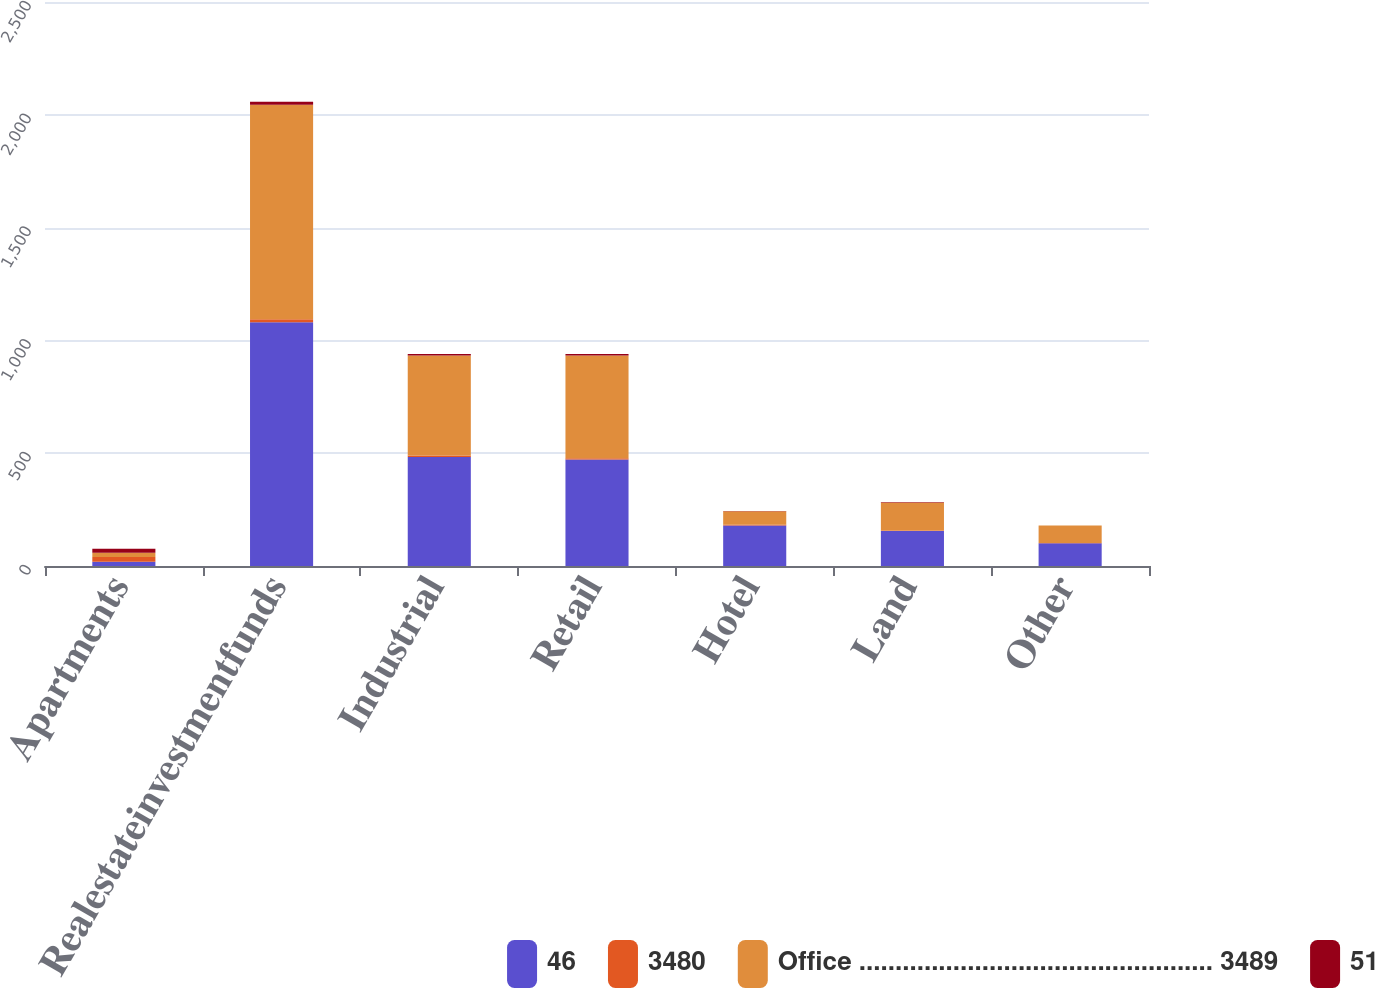Convert chart to OTSL. <chart><loc_0><loc_0><loc_500><loc_500><stacked_bar_chart><ecel><fcel>Apartments<fcel>Realestateinvestmentfunds<fcel>Industrial<fcel>Retail<fcel>Hotel<fcel>Land<fcel>Other<nl><fcel>46<fcel>19<fcel>1080<fcel>483<fcel>472<fcel>180<fcel>155<fcel>101<nl><fcel>3480<fcel>21<fcel>14<fcel>7<fcel>6<fcel>3<fcel>2<fcel>1<nl><fcel>Office ................................................. 3489<fcel>19<fcel>950<fcel>443<fcel>455<fcel>60<fcel>125<fcel>77<nl><fcel>51<fcel>17<fcel>14<fcel>7<fcel>7<fcel>1<fcel>2<fcel>1<nl></chart> 